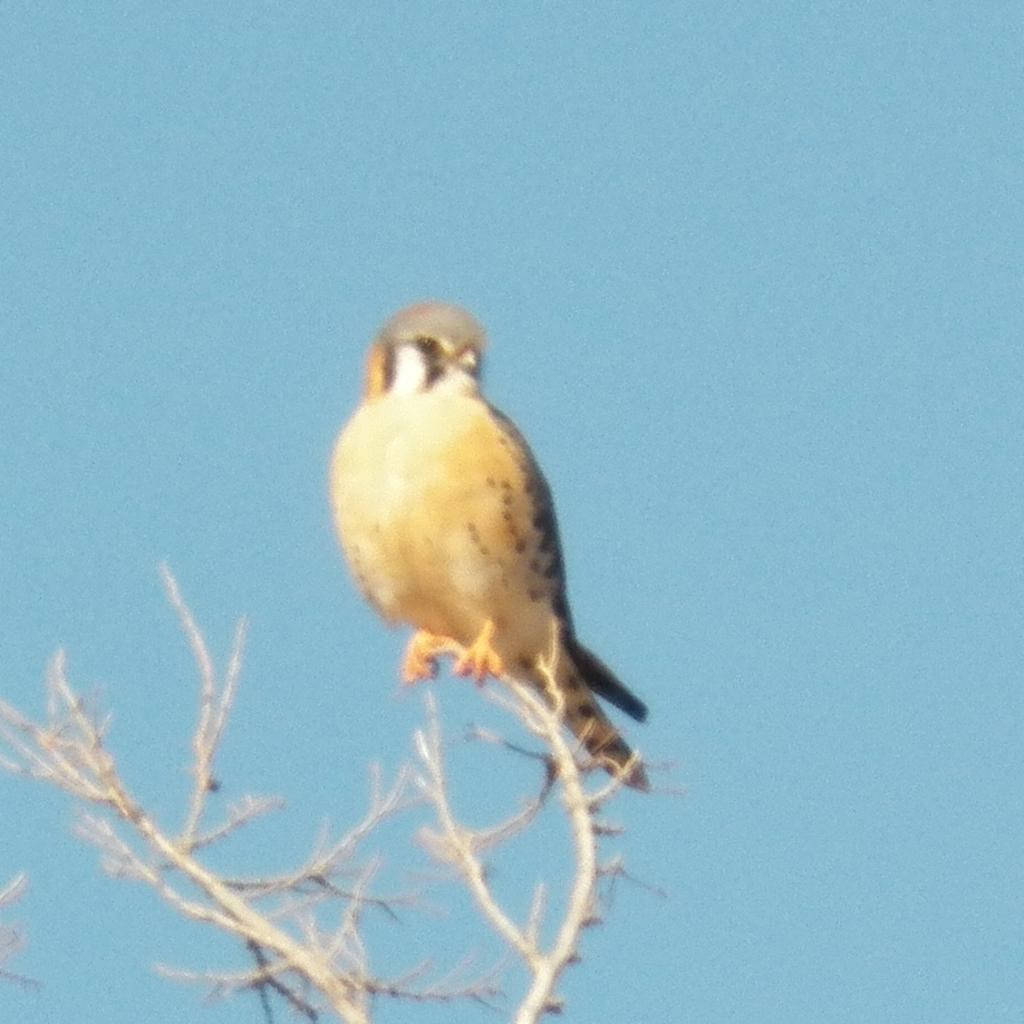What type of animal can be seen in the image? There is a bird in the image. Where is the bird located in the image? The bird is on the branch of a tree. What riddle does the bird solve in the image? There is no riddle present in the image, nor does the bird solve any riddle. How many cats are visible in the image? There are no cats present in the image. 